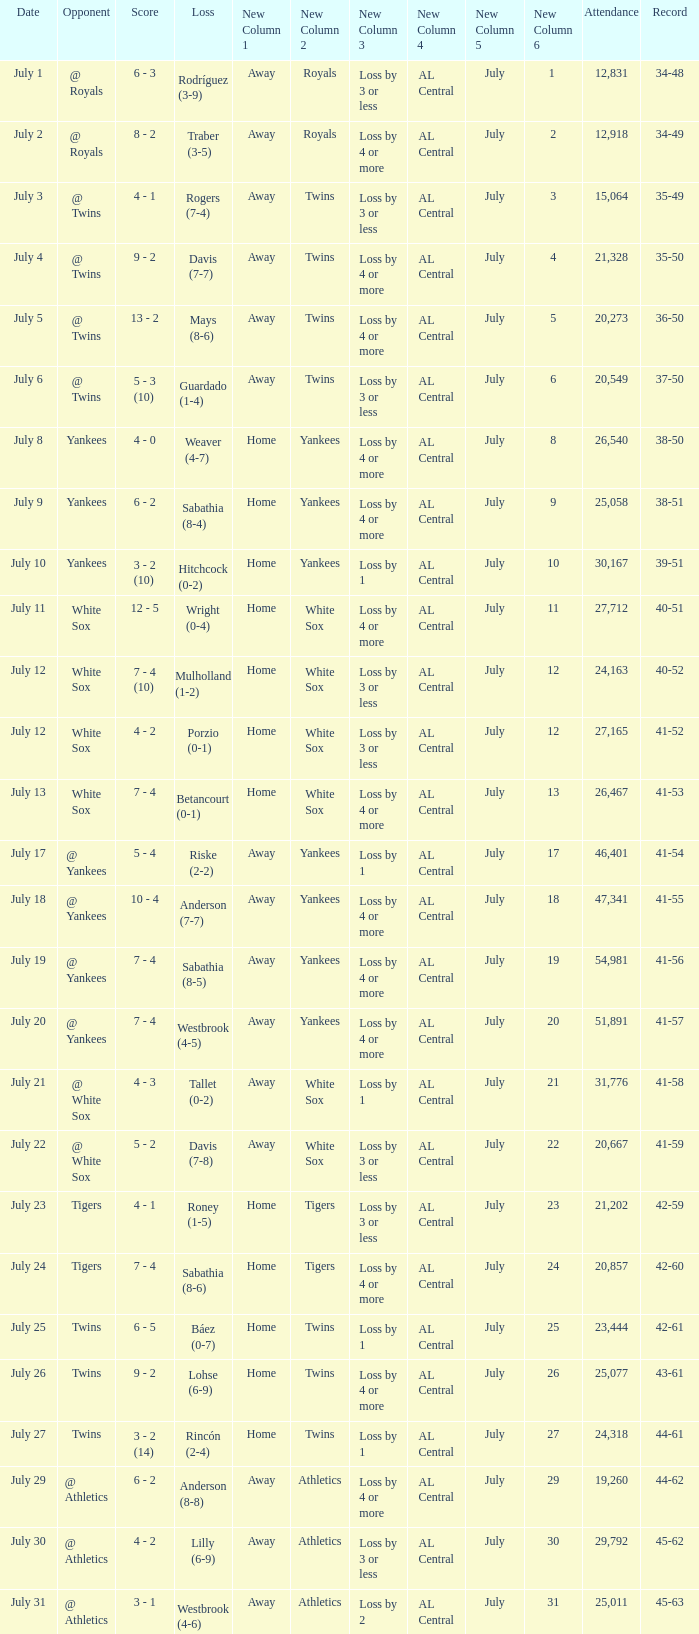Which Record has an Opponent of twins, and a Date of july 25? 42-61. 